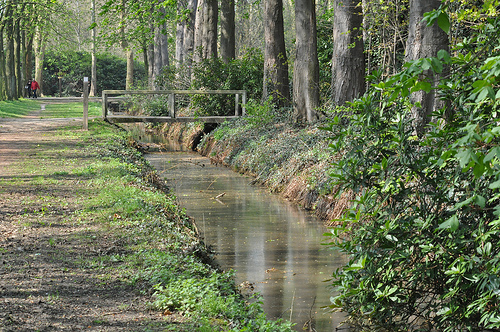<image>
Is the water under the bridge? Yes. The water is positioned underneath the bridge, with the bridge above it in the vertical space. 